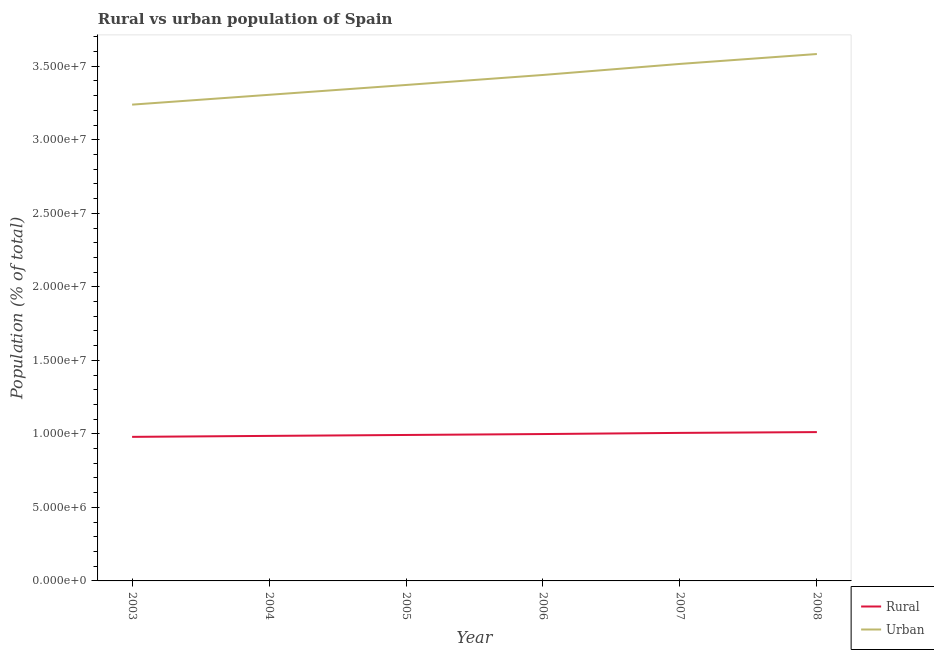How many different coloured lines are there?
Ensure brevity in your answer.  2. Does the line corresponding to urban population density intersect with the line corresponding to rural population density?
Your answer should be compact. No. What is the rural population density in 2005?
Your answer should be very brief. 9.93e+06. Across all years, what is the maximum rural population density?
Give a very brief answer. 1.01e+07. Across all years, what is the minimum urban population density?
Your answer should be very brief. 3.24e+07. What is the total rural population density in the graph?
Give a very brief answer. 5.98e+07. What is the difference between the rural population density in 2003 and that in 2004?
Your answer should be compact. -6.58e+04. What is the difference between the urban population density in 2004 and the rural population density in 2005?
Your answer should be compact. 2.31e+07. What is the average rural population density per year?
Your answer should be compact. 9.96e+06. In the year 2006, what is the difference between the urban population density and rural population density?
Give a very brief answer. 2.44e+07. In how many years, is the rural population density greater than 27000000 %?
Your answer should be very brief. 0. What is the ratio of the rural population density in 2004 to that in 2007?
Provide a short and direct response. 0.98. Is the difference between the rural population density in 2003 and 2005 greater than the difference between the urban population density in 2003 and 2005?
Your answer should be compact. Yes. What is the difference between the highest and the second highest rural population density?
Provide a short and direct response. 5.34e+04. What is the difference between the highest and the lowest rural population density?
Offer a very short reply. 3.24e+05. In how many years, is the urban population density greater than the average urban population density taken over all years?
Provide a succinct answer. 3. Is the sum of the rural population density in 2007 and 2008 greater than the maximum urban population density across all years?
Keep it short and to the point. No. How many years are there in the graph?
Make the answer very short. 6. Does the graph contain grids?
Offer a terse response. No. What is the title of the graph?
Make the answer very short. Rural vs urban population of Spain. What is the label or title of the Y-axis?
Your answer should be very brief. Population (% of total). What is the Population (% of total) in Rural in 2003?
Your answer should be very brief. 9.80e+06. What is the Population (% of total) in Urban in 2003?
Keep it short and to the point. 3.24e+07. What is the Population (% of total) in Rural in 2004?
Ensure brevity in your answer.  9.86e+06. What is the Population (% of total) of Urban in 2004?
Your answer should be compact. 3.31e+07. What is the Population (% of total) in Rural in 2005?
Provide a succinct answer. 9.93e+06. What is the Population (% of total) in Urban in 2005?
Keep it short and to the point. 3.37e+07. What is the Population (% of total) of Rural in 2006?
Your response must be concise. 9.99e+06. What is the Population (% of total) in Urban in 2006?
Make the answer very short. 3.44e+07. What is the Population (% of total) in Rural in 2007?
Your answer should be very brief. 1.01e+07. What is the Population (% of total) in Urban in 2007?
Your answer should be very brief. 3.52e+07. What is the Population (% of total) of Rural in 2008?
Provide a succinct answer. 1.01e+07. What is the Population (% of total) of Urban in 2008?
Provide a short and direct response. 3.58e+07. Across all years, what is the maximum Population (% of total) of Rural?
Ensure brevity in your answer.  1.01e+07. Across all years, what is the maximum Population (% of total) of Urban?
Ensure brevity in your answer.  3.58e+07. Across all years, what is the minimum Population (% of total) in Rural?
Your response must be concise. 9.80e+06. Across all years, what is the minimum Population (% of total) of Urban?
Provide a short and direct response. 3.24e+07. What is the total Population (% of total) in Rural in the graph?
Offer a very short reply. 5.98e+07. What is the total Population (% of total) in Urban in the graph?
Offer a very short reply. 2.05e+08. What is the difference between the Population (% of total) of Rural in 2003 and that in 2004?
Your answer should be compact. -6.58e+04. What is the difference between the Population (% of total) in Urban in 2003 and that in 2004?
Provide a short and direct response. -6.68e+05. What is the difference between the Population (% of total) of Rural in 2003 and that in 2005?
Your answer should be compact. -1.29e+05. What is the difference between the Population (% of total) of Urban in 2003 and that in 2005?
Your answer should be compact. -1.34e+06. What is the difference between the Population (% of total) in Rural in 2003 and that in 2006?
Keep it short and to the point. -1.92e+05. What is the difference between the Population (% of total) in Urban in 2003 and that in 2006?
Ensure brevity in your answer.  -2.02e+06. What is the difference between the Population (% of total) in Rural in 2003 and that in 2007?
Offer a very short reply. -2.71e+05. What is the difference between the Population (% of total) of Urban in 2003 and that in 2007?
Provide a short and direct response. -2.77e+06. What is the difference between the Population (% of total) of Rural in 2003 and that in 2008?
Make the answer very short. -3.24e+05. What is the difference between the Population (% of total) of Urban in 2003 and that in 2008?
Your answer should be compact. -3.44e+06. What is the difference between the Population (% of total) in Rural in 2004 and that in 2005?
Your answer should be very brief. -6.28e+04. What is the difference between the Population (% of total) in Urban in 2004 and that in 2005?
Your response must be concise. -6.68e+05. What is the difference between the Population (% of total) of Rural in 2004 and that in 2006?
Provide a succinct answer. -1.26e+05. What is the difference between the Population (% of total) in Urban in 2004 and that in 2006?
Make the answer very short. -1.35e+06. What is the difference between the Population (% of total) in Rural in 2004 and that in 2007?
Ensure brevity in your answer.  -2.05e+05. What is the difference between the Population (% of total) in Urban in 2004 and that in 2007?
Provide a short and direct response. -2.10e+06. What is the difference between the Population (% of total) of Rural in 2004 and that in 2008?
Offer a terse response. -2.58e+05. What is the difference between the Population (% of total) in Urban in 2004 and that in 2008?
Provide a short and direct response. -2.77e+06. What is the difference between the Population (% of total) of Rural in 2005 and that in 2006?
Your response must be concise. -6.31e+04. What is the difference between the Population (% of total) in Urban in 2005 and that in 2006?
Keep it short and to the point. -6.81e+05. What is the difference between the Population (% of total) in Rural in 2005 and that in 2007?
Keep it short and to the point. -1.42e+05. What is the difference between the Population (% of total) in Urban in 2005 and that in 2007?
Give a very brief answer. -1.43e+06. What is the difference between the Population (% of total) in Rural in 2005 and that in 2008?
Offer a very short reply. -1.96e+05. What is the difference between the Population (% of total) in Urban in 2005 and that in 2008?
Provide a succinct answer. -2.11e+06. What is the difference between the Population (% of total) in Rural in 2006 and that in 2007?
Offer a terse response. -7.90e+04. What is the difference between the Population (% of total) in Urban in 2006 and that in 2007?
Your response must be concise. -7.51e+05. What is the difference between the Population (% of total) of Rural in 2006 and that in 2008?
Make the answer very short. -1.32e+05. What is the difference between the Population (% of total) in Urban in 2006 and that in 2008?
Provide a short and direct response. -1.42e+06. What is the difference between the Population (% of total) in Rural in 2007 and that in 2008?
Your answer should be compact. -5.34e+04. What is the difference between the Population (% of total) of Urban in 2007 and that in 2008?
Offer a terse response. -6.74e+05. What is the difference between the Population (% of total) of Rural in 2003 and the Population (% of total) of Urban in 2004?
Your answer should be compact. -2.33e+07. What is the difference between the Population (% of total) in Rural in 2003 and the Population (% of total) in Urban in 2005?
Offer a very short reply. -2.39e+07. What is the difference between the Population (% of total) in Rural in 2003 and the Population (% of total) in Urban in 2006?
Ensure brevity in your answer.  -2.46e+07. What is the difference between the Population (% of total) of Rural in 2003 and the Population (% of total) of Urban in 2007?
Give a very brief answer. -2.54e+07. What is the difference between the Population (% of total) of Rural in 2003 and the Population (% of total) of Urban in 2008?
Make the answer very short. -2.60e+07. What is the difference between the Population (% of total) of Rural in 2004 and the Population (% of total) of Urban in 2005?
Provide a succinct answer. -2.39e+07. What is the difference between the Population (% of total) of Rural in 2004 and the Population (% of total) of Urban in 2006?
Offer a terse response. -2.45e+07. What is the difference between the Population (% of total) of Rural in 2004 and the Population (% of total) of Urban in 2007?
Provide a succinct answer. -2.53e+07. What is the difference between the Population (% of total) in Rural in 2004 and the Population (% of total) in Urban in 2008?
Keep it short and to the point. -2.60e+07. What is the difference between the Population (% of total) of Rural in 2005 and the Population (% of total) of Urban in 2006?
Your response must be concise. -2.45e+07. What is the difference between the Population (% of total) in Rural in 2005 and the Population (% of total) in Urban in 2007?
Offer a very short reply. -2.52e+07. What is the difference between the Population (% of total) of Rural in 2005 and the Population (% of total) of Urban in 2008?
Your answer should be very brief. -2.59e+07. What is the difference between the Population (% of total) of Rural in 2006 and the Population (% of total) of Urban in 2007?
Your answer should be compact. -2.52e+07. What is the difference between the Population (% of total) of Rural in 2006 and the Population (% of total) of Urban in 2008?
Provide a short and direct response. -2.58e+07. What is the difference between the Population (% of total) in Rural in 2007 and the Population (% of total) in Urban in 2008?
Make the answer very short. -2.58e+07. What is the average Population (% of total) in Rural per year?
Keep it short and to the point. 9.96e+06. What is the average Population (% of total) in Urban per year?
Keep it short and to the point. 3.41e+07. In the year 2003, what is the difference between the Population (% of total) of Rural and Population (% of total) of Urban?
Offer a terse response. -2.26e+07. In the year 2004, what is the difference between the Population (% of total) of Rural and Population (% of total) of Urban?
Your response must be concise. -2.32e+07. In the year 2005, what is the difference between the Population (% of total) in Rural and Population (% of total) in Urban?
Offer a very short reply. -2.38e+07. In the year 2006, what is the difference between the Population (% of total) in Rural and Population (% of total) in Urban?
Provide a short and direct response. -2.44e+07. In the year 2007, what is the difference between the Population (% of total) of Rural and Population (% of total) of Urban?
Offer a terse response. -2.51e+07. In the year 2008, what is the difference between the Population (% of total) of Rural and Population (% of total) of Urban?
Give a very brief answer. -2.57e+07. What is the ratio of the Population (% of total) of Urban in 2003 to that in 2004?
Offer a terse response. 0.98. What is the ratio of the Population (% of total) in Urban in 2003 to that in 2005?
Give a very brief answer. 0.96. What is the ratio of the Population (% of total) of Rural in 2003 to that in 2006?
Make the answer very short. 0.98. What is the ratio of the Population (% of total) in Urban in 2003 to that in 2006?
Offer a very short reply. 0.94. What is the ratio of the Population (% of total) in Rural in 2003 to that in 2007?
Keep it short and to the point. 0.97. What is the ratio of the Population (% of total) of Urban in 2003 to that in 2007?
Your response must be concise. 0.92. What is the ratio of the Population (% of total) of Rural in 2003 to that in 2008?
Your answer should be very brief. 0.97. What is the ratio of the Population (% of total) of Urban in 2003 to that in 2008?
Provide a short and direct response. 0.9. What is the ratio of the Population (% of total) of Rural in 2004 to that in 2005?
Your response must be concise. 0.99. What is the ratio of the Population (% of total) of Urban in 2004 to that in 2005?
Offer a terse response. 0.98. What is the ratio of the Population (% of total) in Rural in 2004 to that in 2006?
Your response must be concise. 0.99. What is the ratio of the Population (% of total) of Urban in 2004 to that in 2006?
Offer a terse response. 0.96. What is the ratio of the Population (% of total) in Rural in 2004 to that in 2007?
Keep it short and to the point. 0.98. What is the ratio of the Population (% of total) in Urban in 2004 to that in 2007?
Ensure brevity in your answer.  0.94. What is the ratio of the Population (% of total) in Rural in 2004 to that in 2008?
Make the answer very short. 0.97. What is the ratio of the Population (% of total) in Urban in 2004 to that in 2008?
Give a very brief answer. 0.92. What is the ratio of the Population (% of total) of Urban in 2005 to that in 2006?
Your answer should be compact. 0.98. What is the ratio of the Population (% of total) in Rural in 2005 to that in 2007?
Provide a succinct answer. 0.99. What is the ratio of the Population (% of total) in Urban in 2005 to that in 2007?
Your answer should be very brief. 0.96. What is the ratio of the Population (% of total) of Rural in 2005 to that in 2008?
Offer a very short reply. 0.98. What is the ratio of the Population (% of total) in Urban in 2006 to that in 2007?
Your answer should be compact. 0.98. What is the ratio of the Population (% of total) of Rural in 2006 to that in 2008?
Make the answer very short. 0.99. What is the ratio of the Population (% of total) of Urban in 2006 to that in 2008?
Your response must be concise. 0.96. What is the ratio of the Population (% of total) of Urban in 2007 to that in 2008?
Offer a very short reply. 0.98. What is the difference between the highest and the second highest Population (% of total) in Rural?
Offer a very short reply. 5.34e+04. What is the difference between the highest and the second highest Population (% of total) in Urban?
Make the answer very short. 6.74e+05. What is the difference between the highest and the lowest Population (% of total) of Rural?
Give a very brief answer. 3.24e+05. What is the difference between the highest and the lowest Population (% of total) of Urban?
Give a very brief answer. 3.44e+06. 